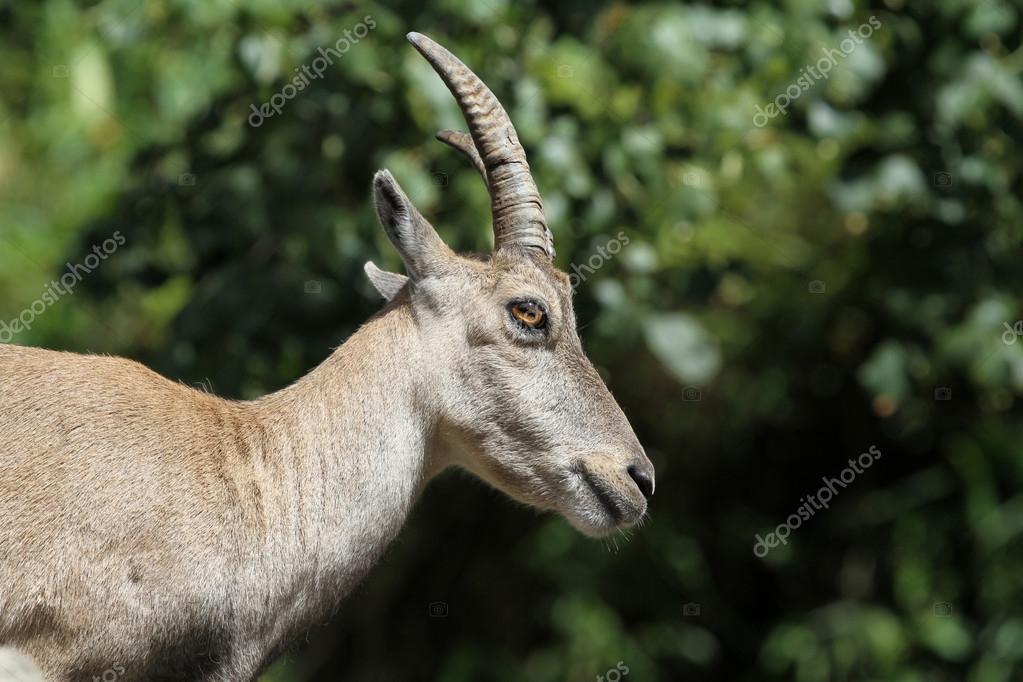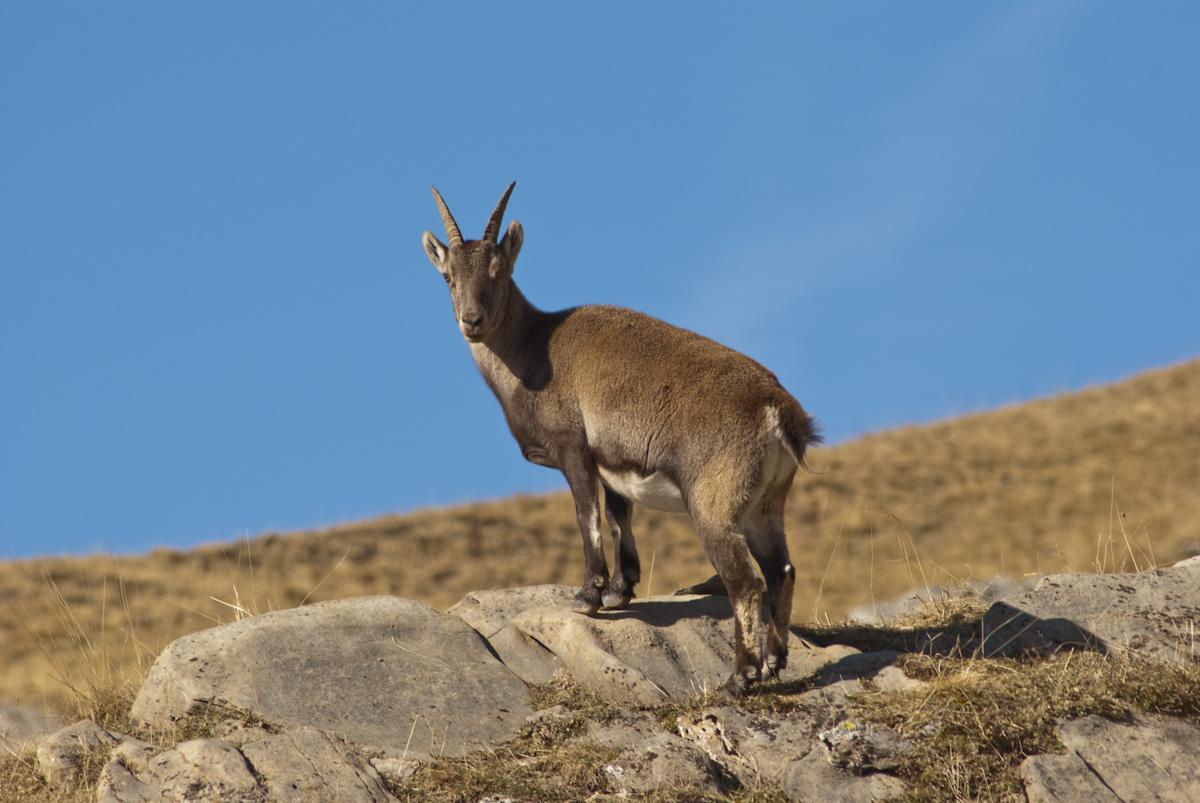The first image is the image on the left, the second image is the image on the right. Given the left and right images, does the statement "The left and right image contains the same number of goats with at least one one rocks." hold true? Answer yes or no. Yes. The first image is the image on the left, the second image is the image on the right. Evaluate the accuracy of this statement regarding the images: "The left image has a single mammal looking to the right, the right image has a single mammal not looking to the right.". Is it true? Answer yes or no. Yes. 